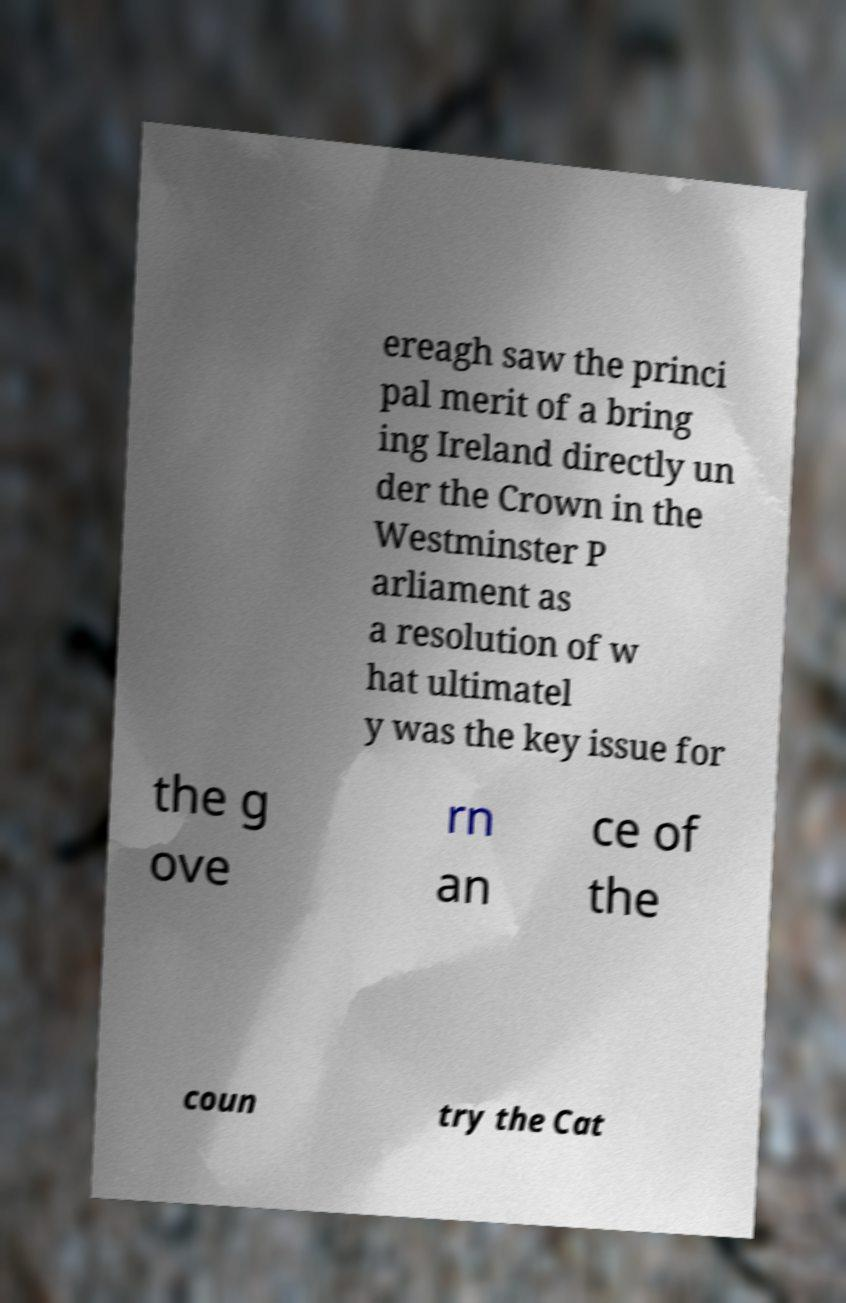Can you accurately transcribe the text from the provided image for me? ereagh saw the princi pal merit of a bring ing Ireland directly un der the Crown in the Westminster P arliament as a resolution of w hat ultimatel y was the key issue for the g ove rn an ce of the coun try the Cat 